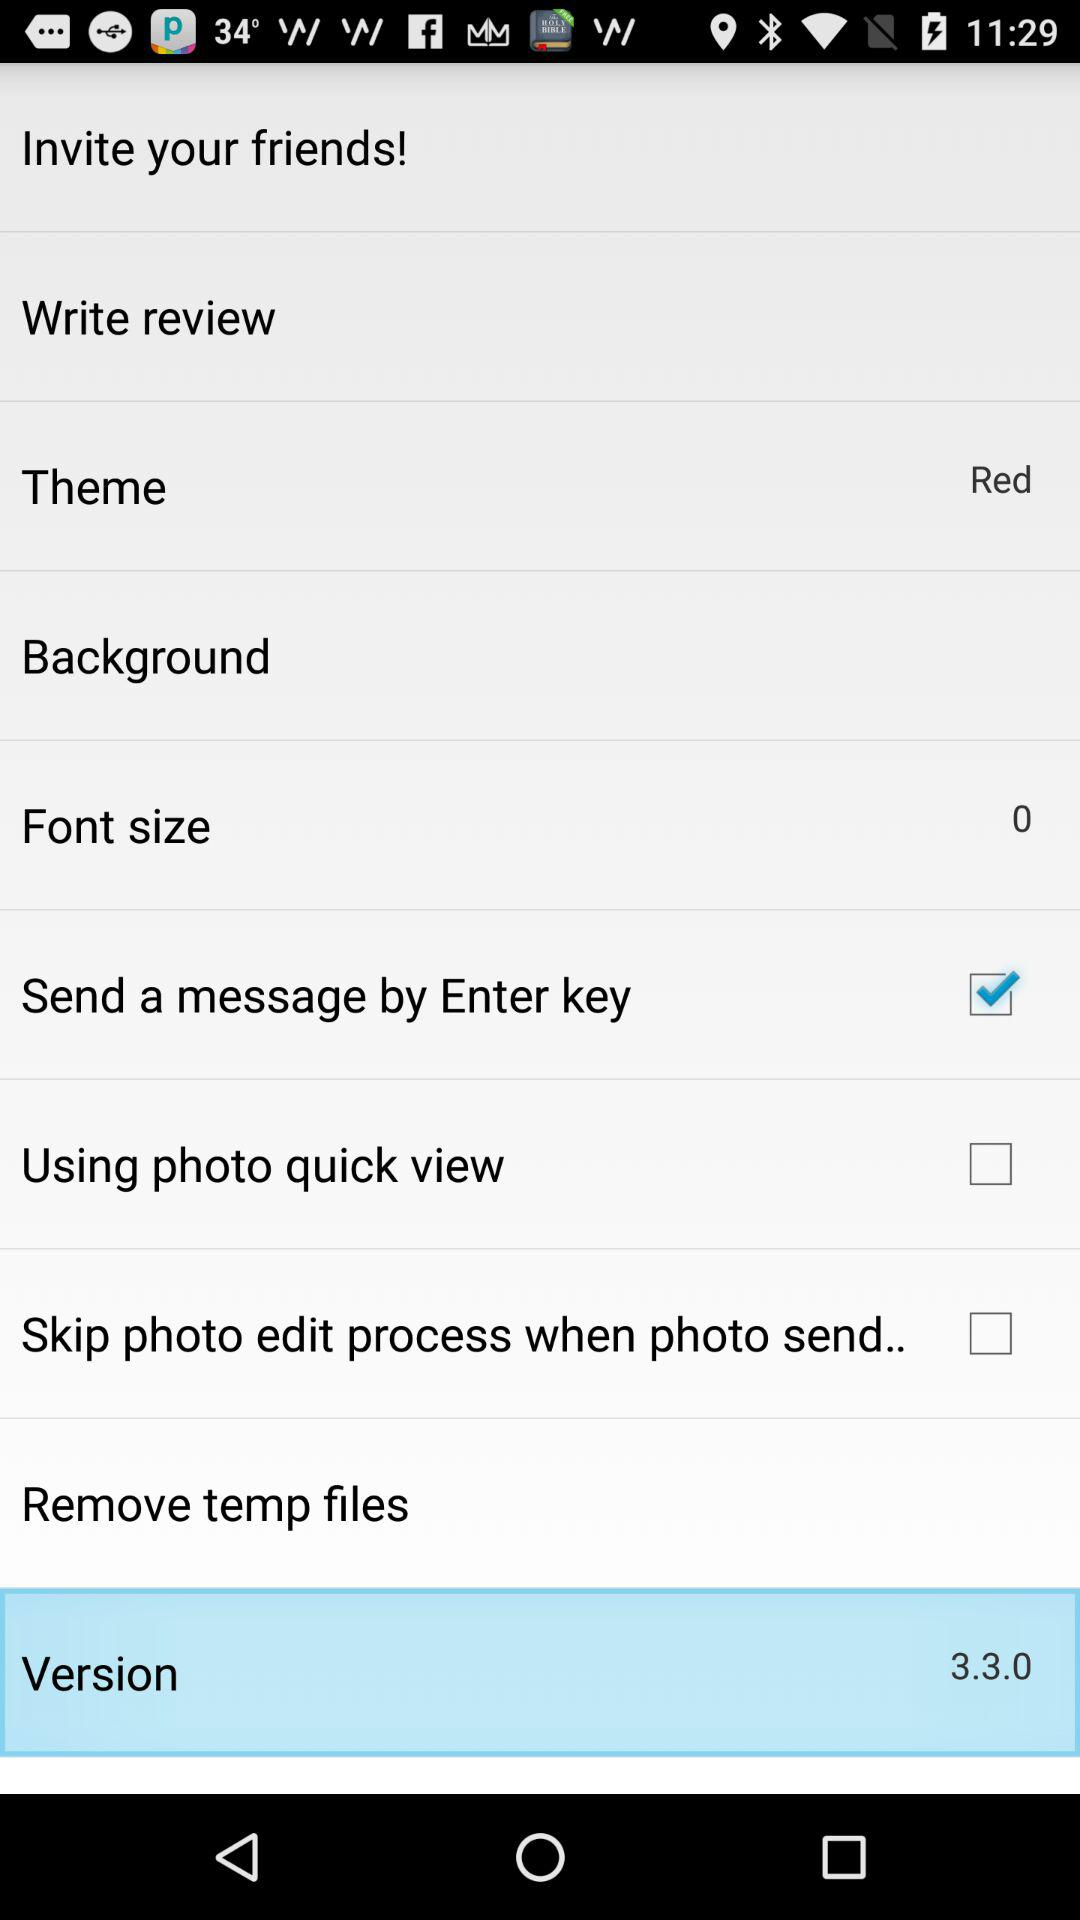What check box is selected? The selected checkbox is "Send a message by Enter key". 